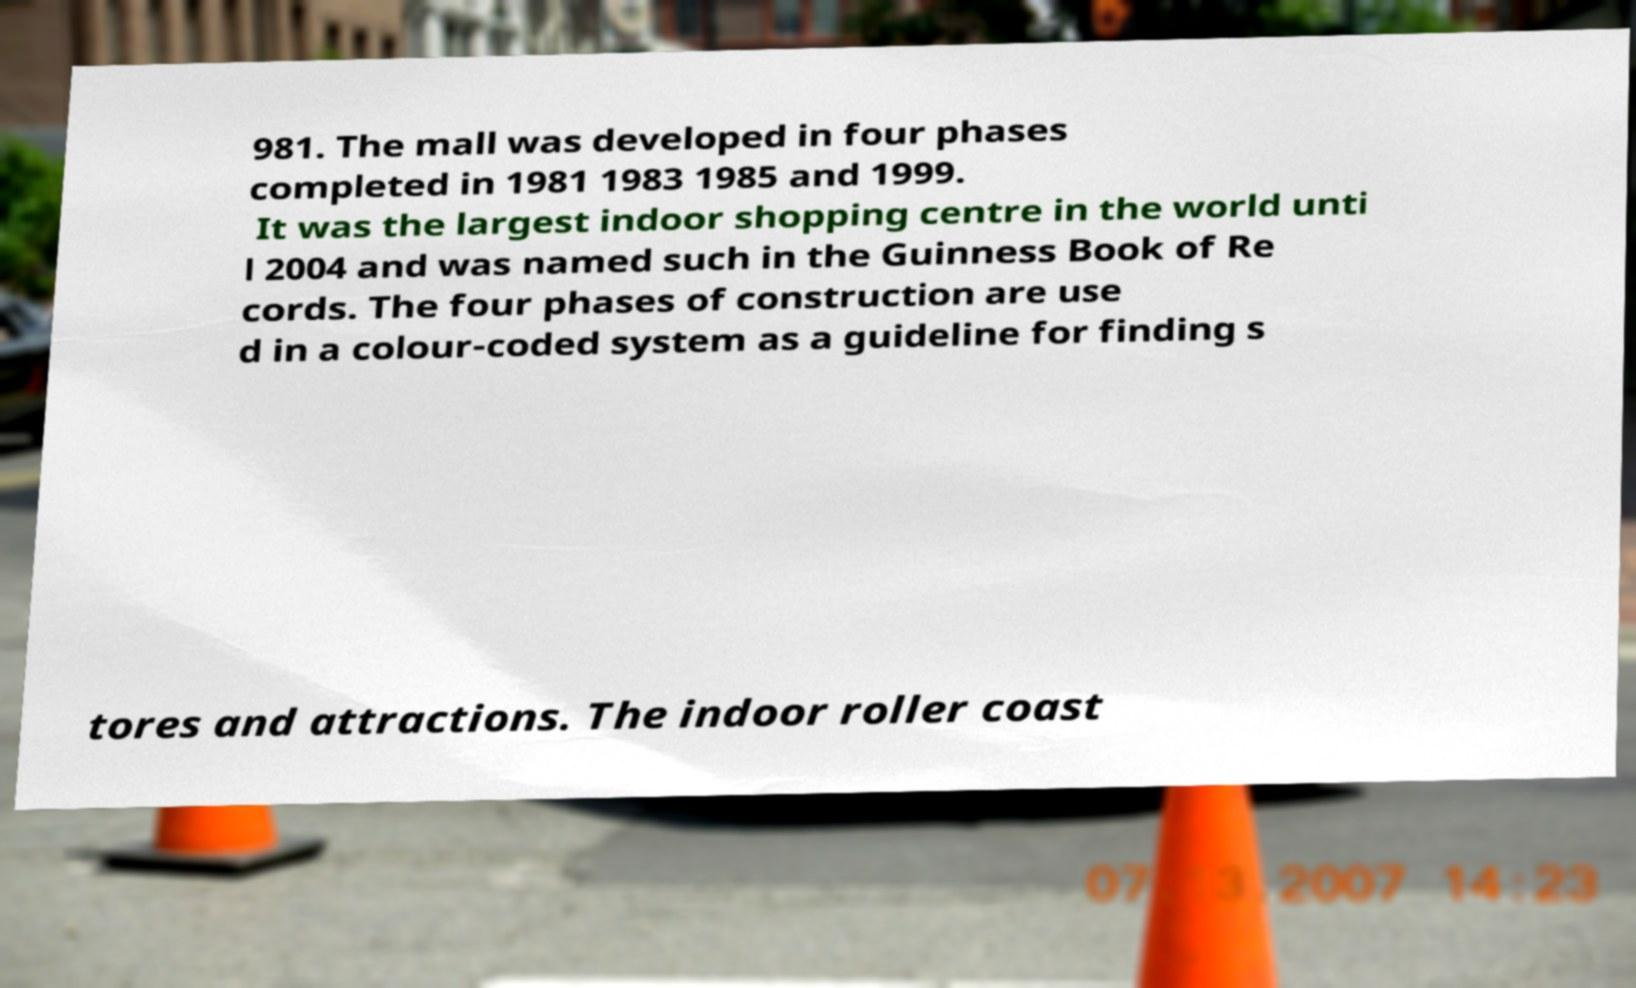Please read and relay the text visible in this image. What does it say? 981. The mall was developed in four phases completed in 1981 1983 1985 and 1999. It was the largest indoor shopping centre in the world unti l 2004 and was named such in the Guinness Book of Re cords. The four phases of construction are use d in a colour-coded system as a guideline for finding s tores and attractions. The indoor roller coast 